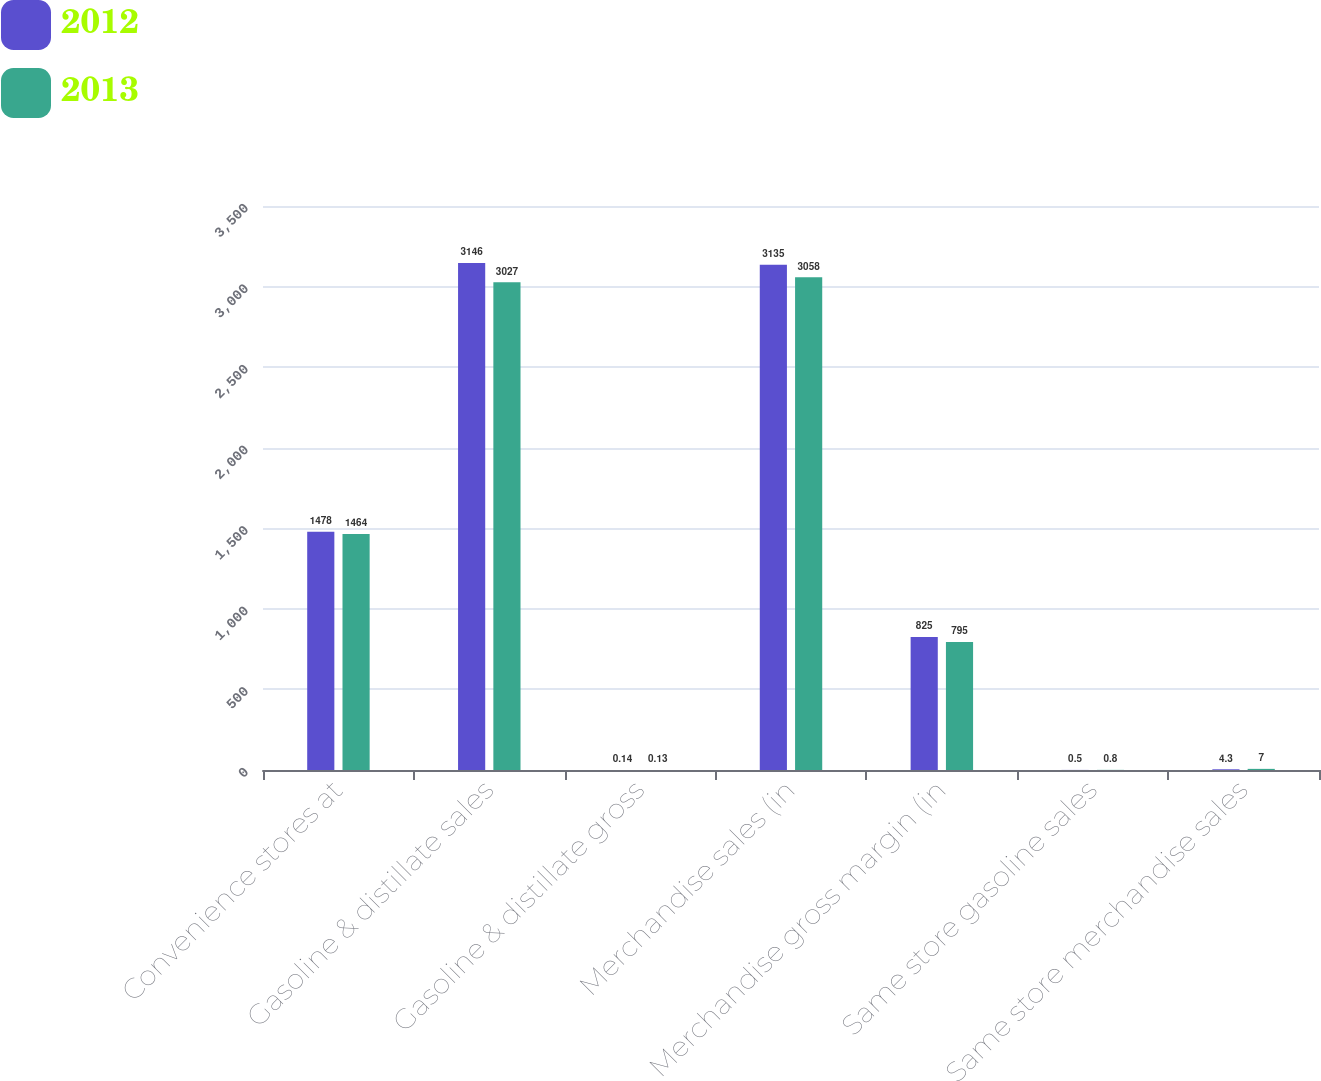Convert chart. <chart><loc_0><loc_0><loc_500><loc_500><stacked_bar_chart><ecel><fcel>Convenience stores at<fcel>Gasoline & distillate sales<fcel>Gasoline & distillate gross<fcel>Merchandise sales (in<fcel>Merchandise gross margin (in<fcel>Same store gasoline sales<fcel>Same store merchandise sales<nl><fcel>2012<fcel>1478<fcel>3146<fcel>0.14<fcel>3135<fcel>825<fcel>0.5<fcel>4.3<nl><fcel>2013<fcel>1464<fcel>3027<fcel>0.13<fcel>3058<fcel>795<fcel>0.8<fcel>7<nl></chart> 